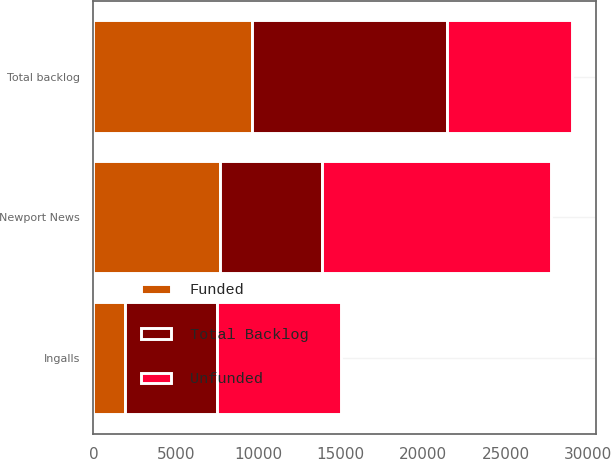<chart> <loc_0><loc_0><loc_500><loc_500><stacked_bar_chart><ecel><fcel>Ingalls<fcel>Newport News<fcel>Total backlog<nl><fcel>Total Backlog<fcel>5609<fcel>6158<fcel>11832<nl><fcel>Funded<fcel>1889<fcel>7709<fcel>9598<nl><fcel>Unfunded<fcel>7498<fcel>13867<fcel>7603.5<nl></chart> 